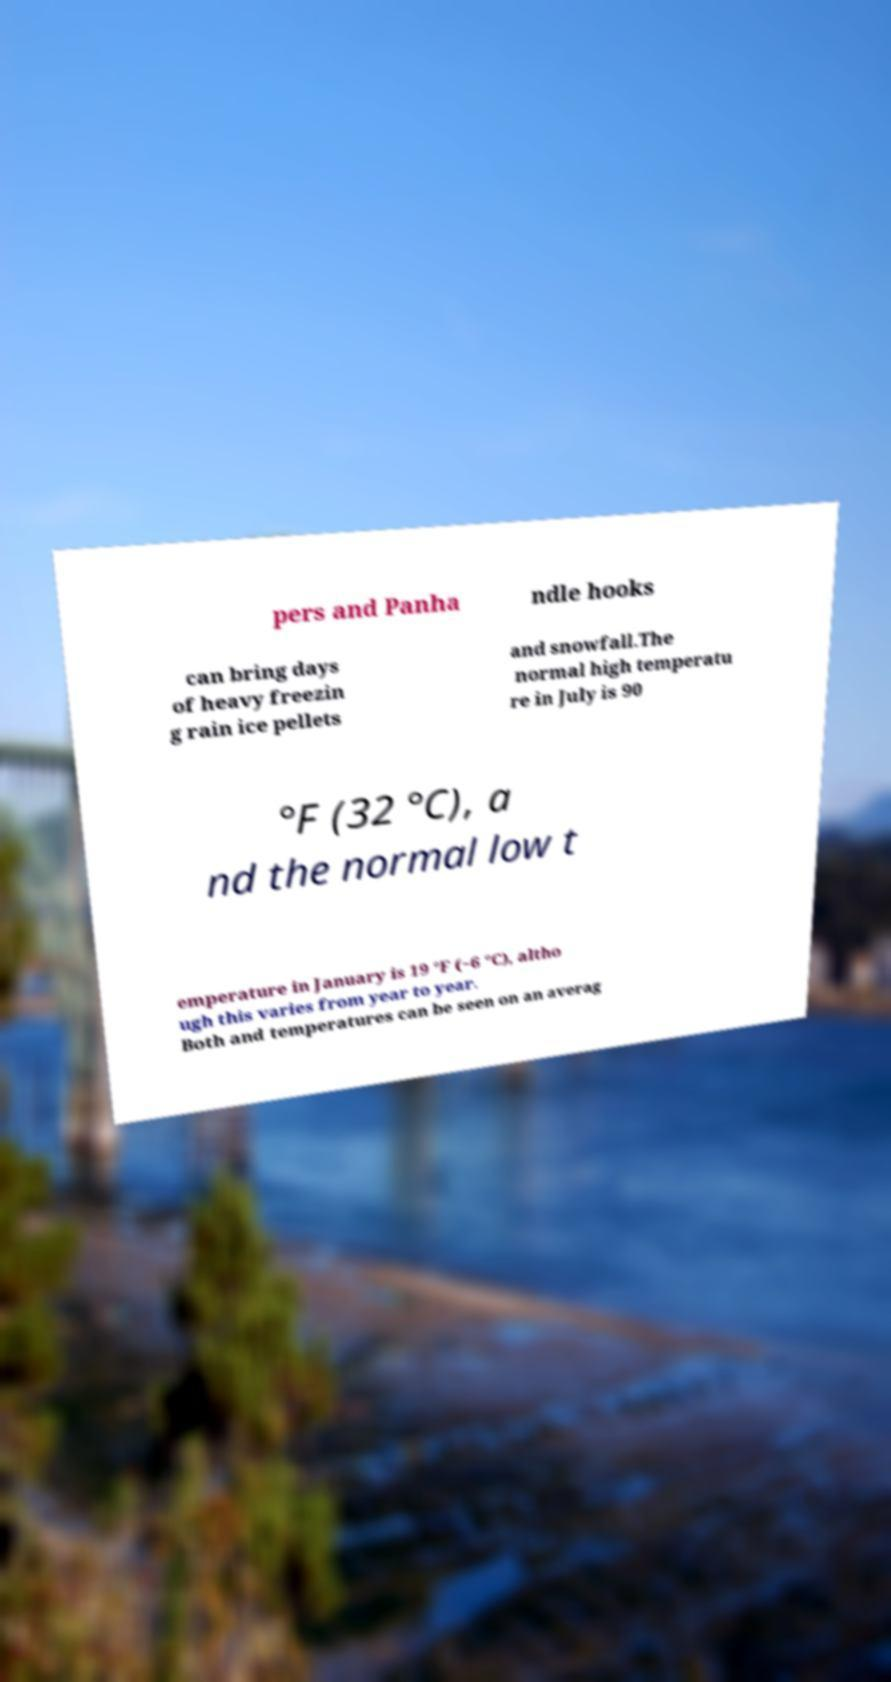Can you read and provide the text displayed in the image?This photo seems to have some interesting text. Can you extract and type it out for me? pers and Panha ndle hooks can bring days of heavy freezin g rain ice pellets and snowfall.The normal high temperatu re in July is 90 °F (32 °C), a nd the normal low t emperature in January is 19 °F (−6 °C), altho ugh this varies from year to year. Both and temperatures can be seen on an averag 